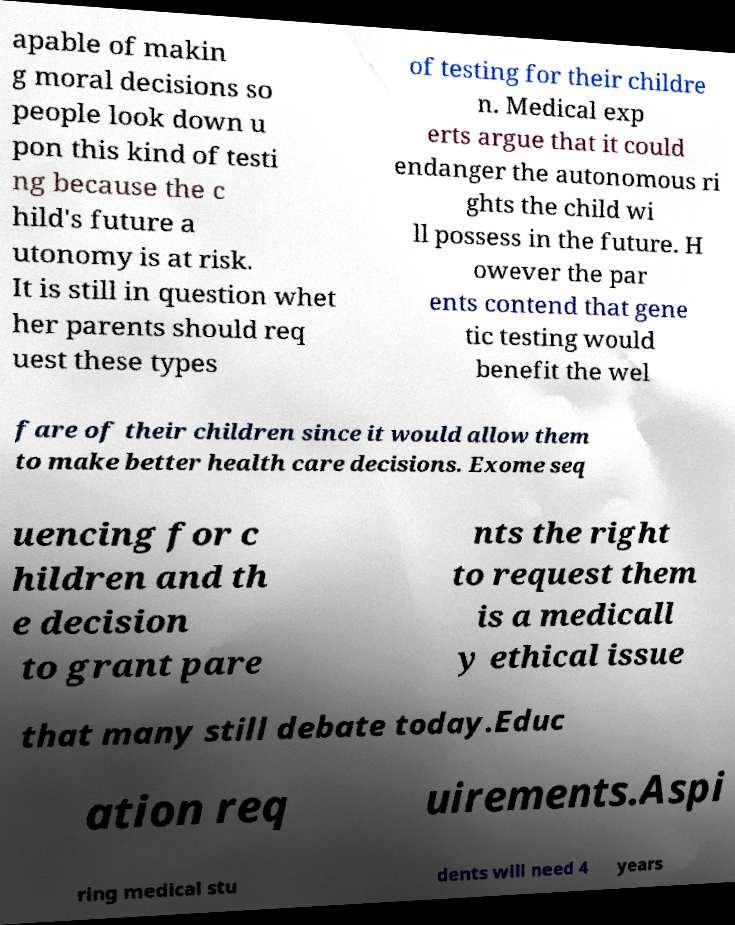Could you extract and type out the text from this image? apable of makin g moral decisions so people look down u pon this kind of testi ng because the c hild's future a utonomy is at risk. It is still in question whet her parents should req uest these types of testing for their childre n. Medical exp erts argue that it could endanger the autonomous ri ghts the child wi ll possess in the future. H owever the par ents contend that gene tic testing would benefit the wel fare of their children since it would allow them to make better health care decisions. Exome seq uencing for c hildren and th e decision to grant pare nts the right to request them is a medicall y ethical issue that many still debate today.Educ ation req uirements.Aspi ring medical stu dents will need 4 years 